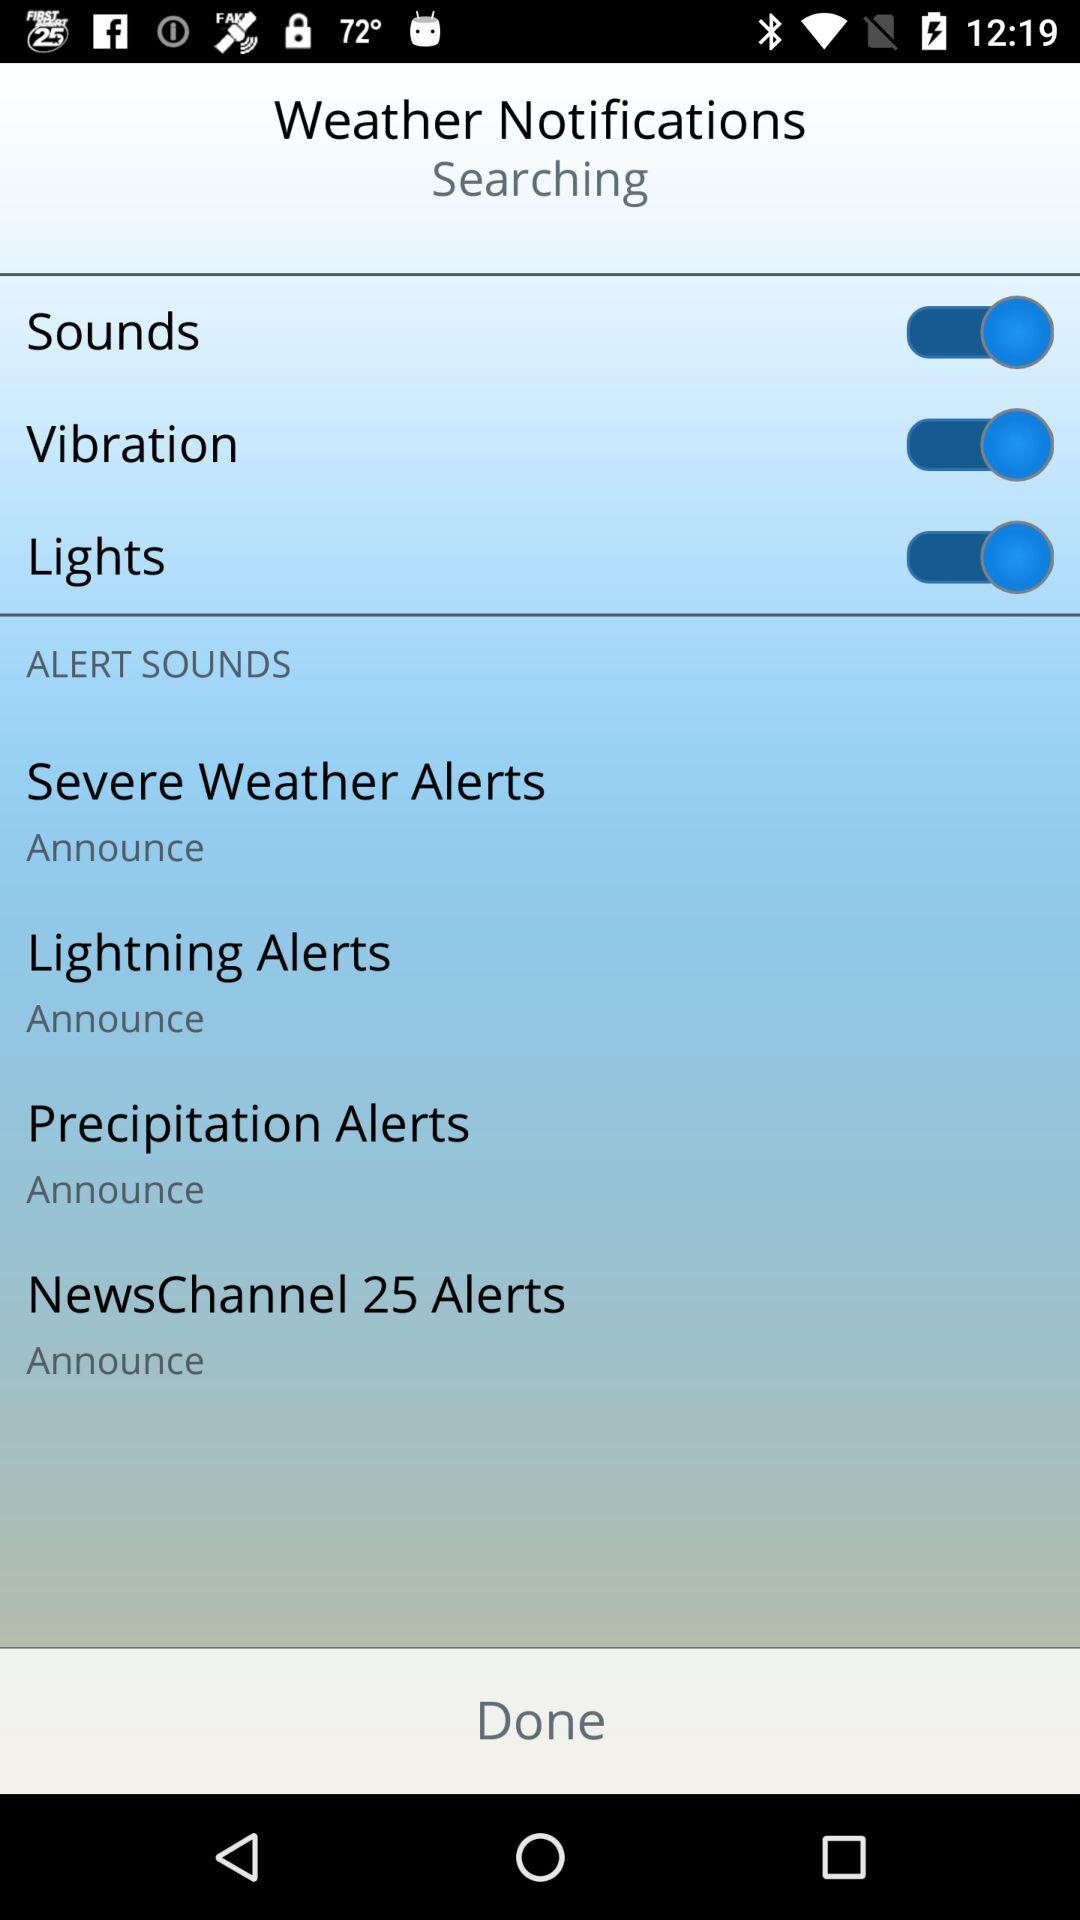What's the status of "Sounds"? The status is "on". 